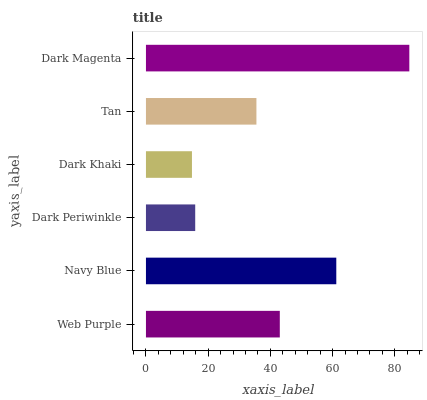Is Dark Khaki the minimum?
Answer yes or no. Yes. Is Dark Magenta the maximum?
Answer yes or no. Yes. Is Navy Blue the minimum?
Answer yes or no. No. Is Navy Blue the maximum?
Answer yes or no. No. Is Navy Blue greater than Web Purple?
Answer yes or no. Yes. Is Web Purple less than Navy Blue?
Answer yes or no. Yes. Is Web Purple greater than Navy Blue?
Answer yes or no. No. Is Navy Blue less than Web Purple?
Answer yes or no. No. Is Web Purple the high median?
Answer yes or no. Yes. Is Tan the low median?
Answer yes or no. Yes. Is Dark Periwinkle the high median?
Answer yes or no. No. Is Dark Khaki the low median?
Answer yes or no. No. 